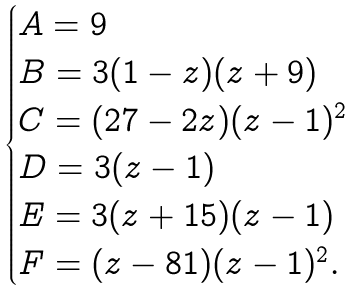<formula> <loc_0><loc_0><loc_500><loc_500>\begin{cases} A = 9 \\ B = 3 ( 1 - z ) ( z + 9 ) \\ C = ( 2 7 - 2 z ) ( z - 1 ) ^ { 2 } \\ D = 3 ( z - 1 ) \\ E = 3 ( z + 1 5 ) ( z - 1 ) \\ F = ( z - 8 1 ) ( z - 1 ) ^ { 2 } . \end{cases}</formula> 